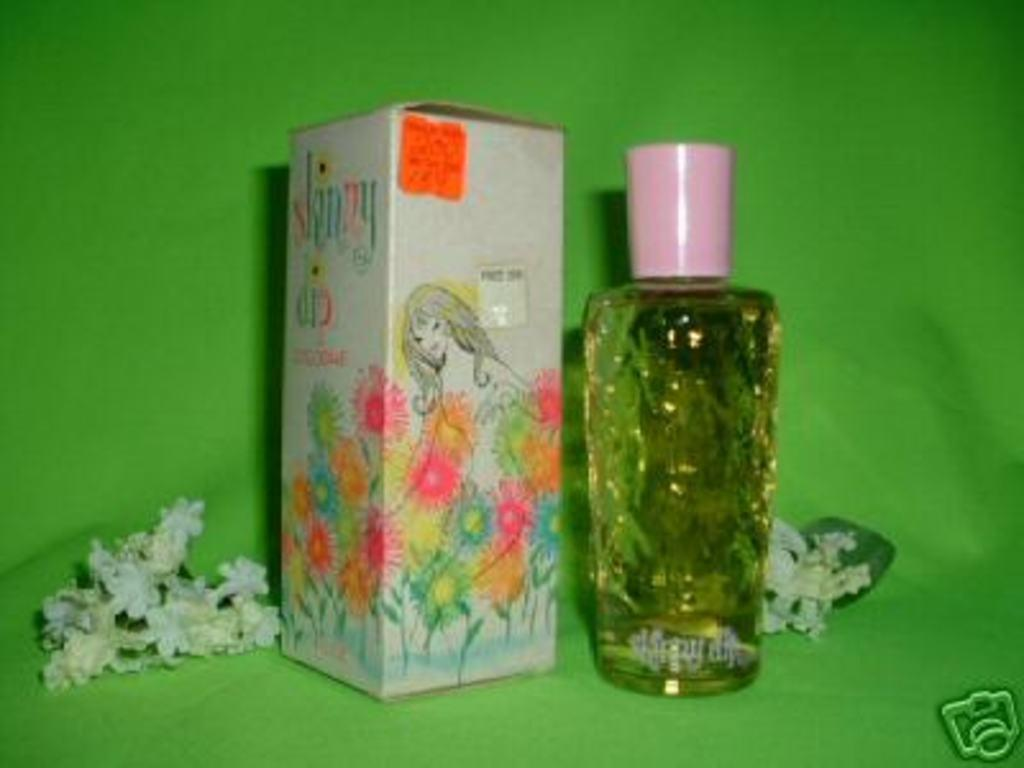Provide a one-sentence caption for the provided image. Bottle of perfume next to a box with the word "skinny" on it. 